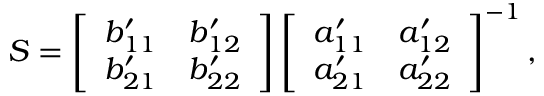Convert formula to latex. <formula><loc_0><loc_0><loc_500><loc_500>S = \left [ \begin{array} { l l } { b _ { 1 1 } ^ { \prime } } & { b _ { 1 2 } ^ { \prime } } \\ { b _ { 2 1 } ^ { \prime } } & { b _ { 2 2 } ^ { \prime } } \end{array} \right ] \left [ \begin{array} { l l } { a _ { 1 1 } ^ { \prime } } & { a _ { 1 2 } ^ { \prime } } \\ { a _ { 2 1 } ^ { \prime } } & { a _ { 2 2 } ^ { \prime } } \end{array} \right ] ^ { - 1 } ,</formula> 